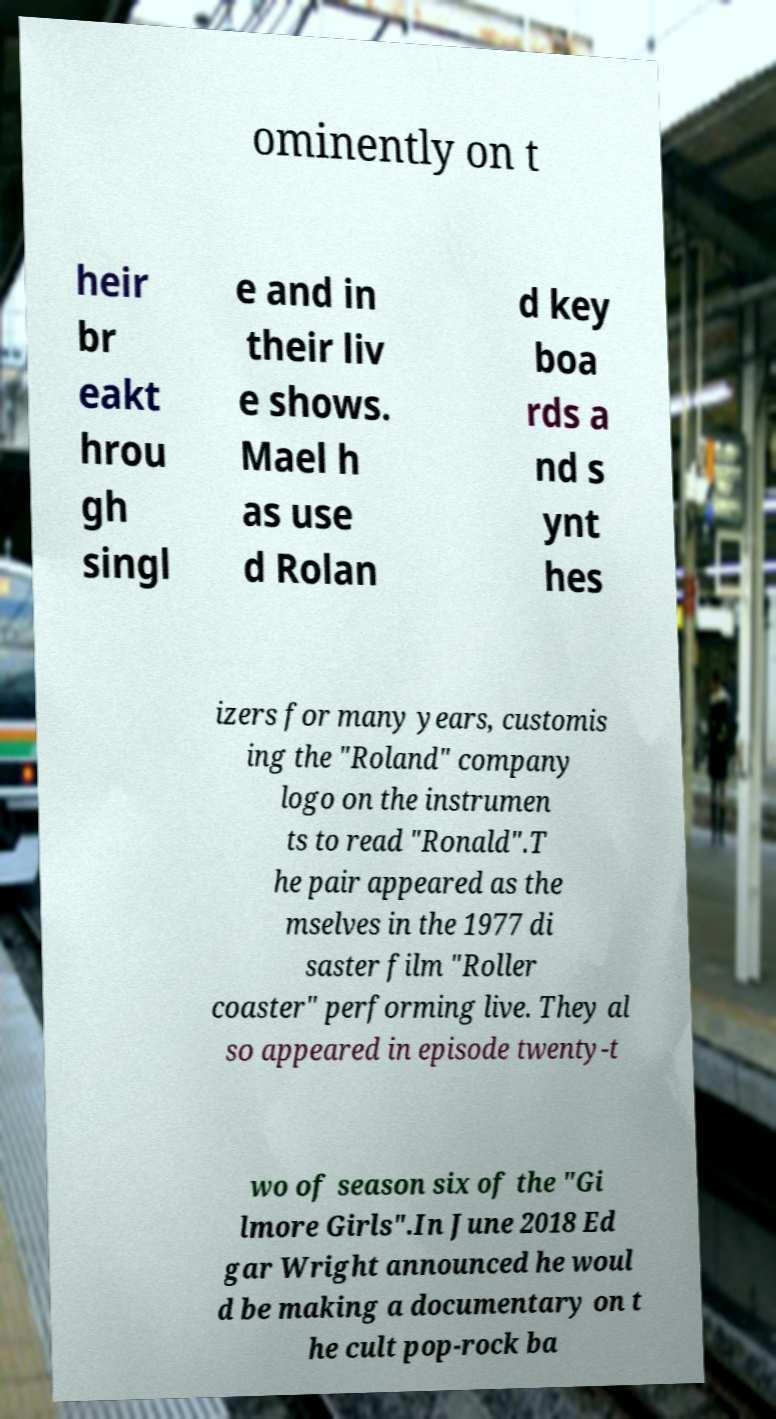I need the written content from this picture converted into text. Can you do that? ominently on t heir br eakt hrou gh singl e and in their liv e shows. Mael h as use d Rolan d key boa rds a nd s ynt hes izers for many years, customis ing the "Roland" company logo on the instrumen ts to read "Ronald".T he pair appeared as the mselves in the 1977 di saster film "Roller coaster" performing live. They al so appeared in episode twenty-t wo of season six of the "Gi lmore Girls".In June 2018 Ed gar Wright announced he woul d be making a documentary on t he cult pop-rock ba 